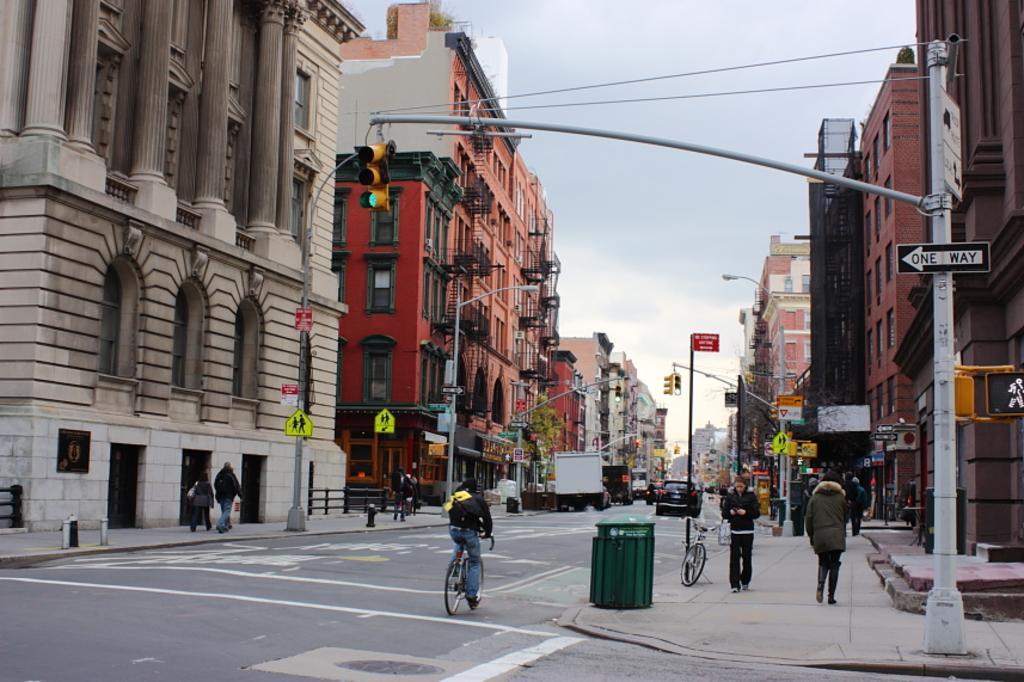Describe this image in one or two sentences. In this image I can see a road in the centre and on it I can see number of vehicles. I can also see few people in the front where one person is sitting on the bicycle in the centre and rest all are standing. On the both side of the road I can see number of poles, street lights, signal lights, sign boards and number of buildings. I can also see a green colour thing in the front and in the background I can see the sky. 